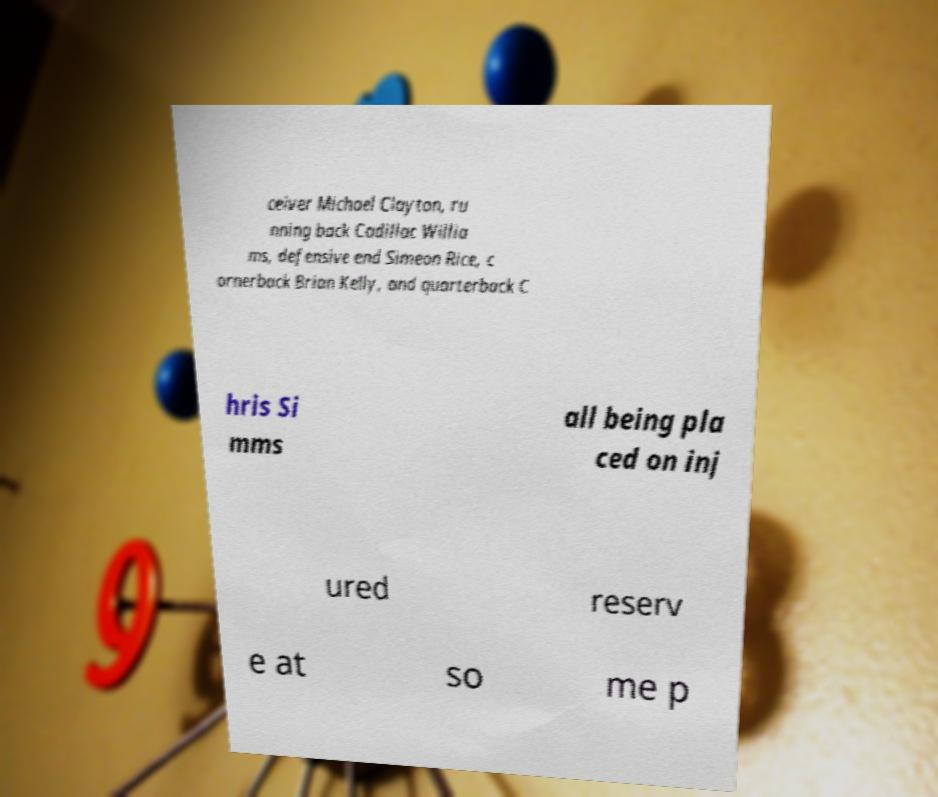Can you read and provide the text displayed in the image?This photo seems to have some interesting text. Can you extract and type it out for me? ceiver Michael Clayton, ru nning back Cadillac Willia ms, defensive end Simeon Rice, c ornerback Brian Kelly, and quarterback C hris Si mms all being pla ced on inj ured reserv e at so me p 